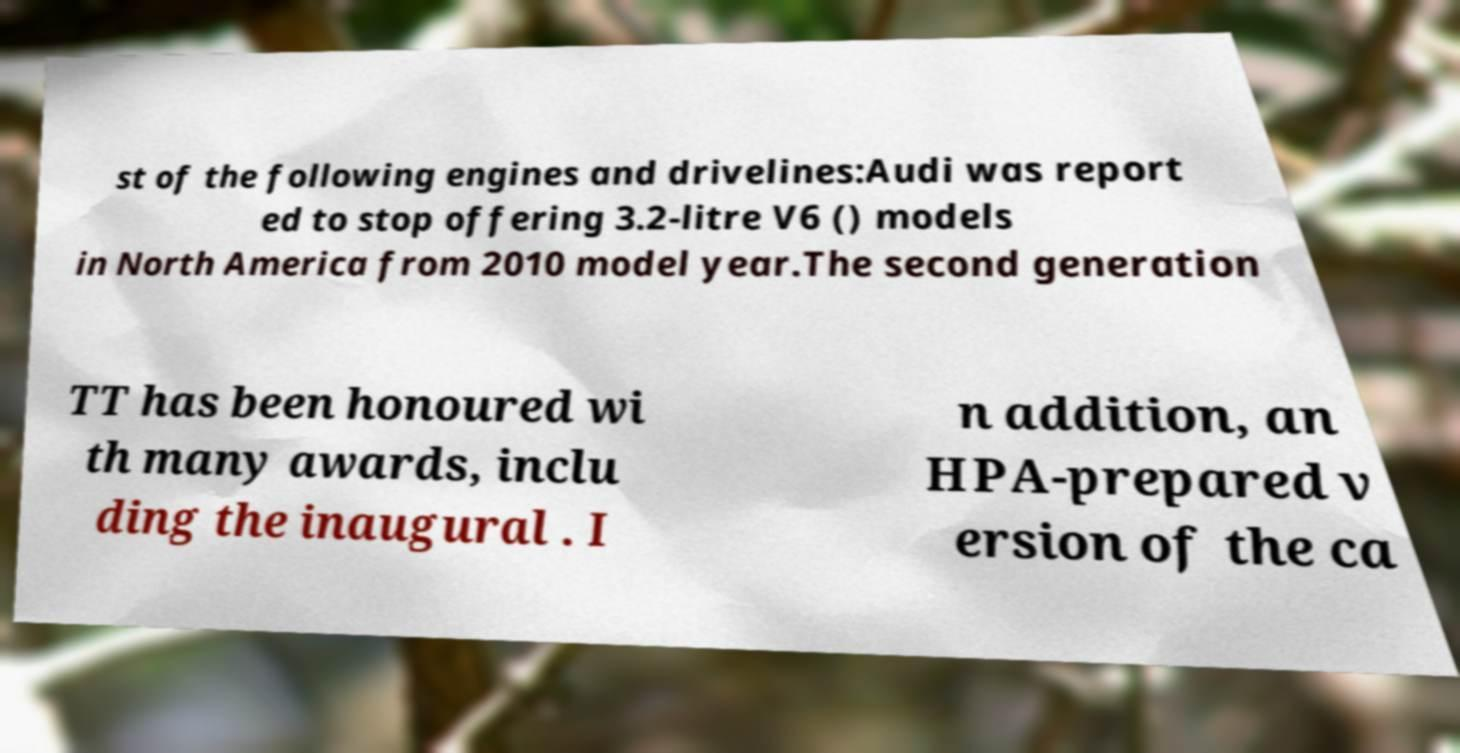Can you accurately transcribe the text from the provided image for me? st of the following engines and drivelines:Audi was report ed to stop offering 3.2-litre V6 () models in North America from 2010 model year.The second generation TT has been honoured wi th many awards, inclu ding the inaugural . I n addition, an HPA-prepared v ersion of the ca 